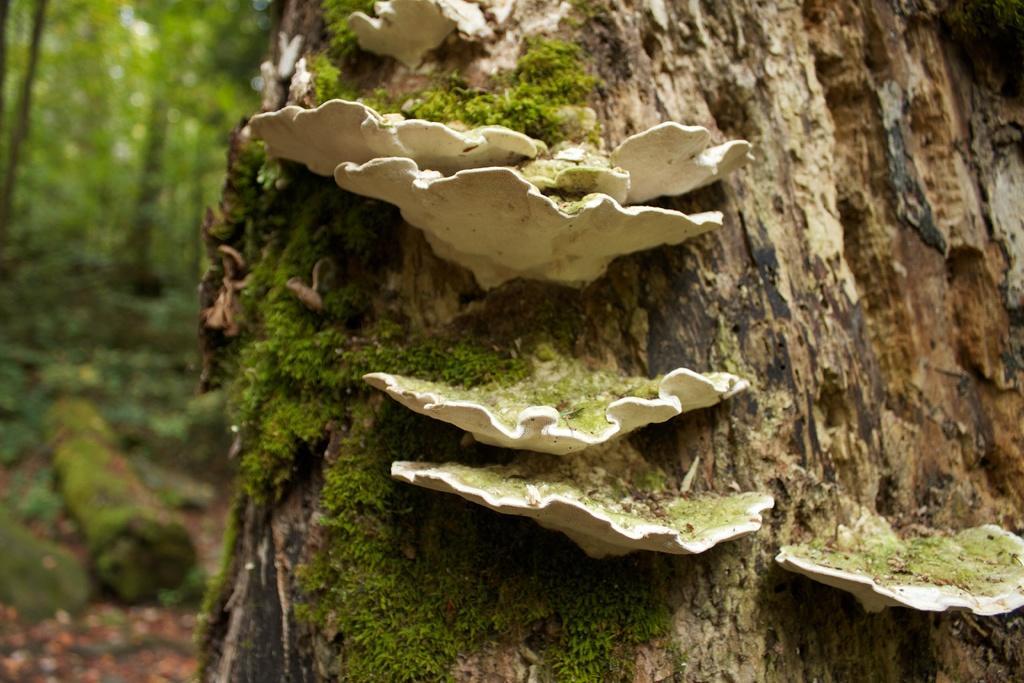Describe this image in one or two sentences. In the center of the image we can see one tree and mushrooms, which are in white color. In the background we can see trees, grass etc. 